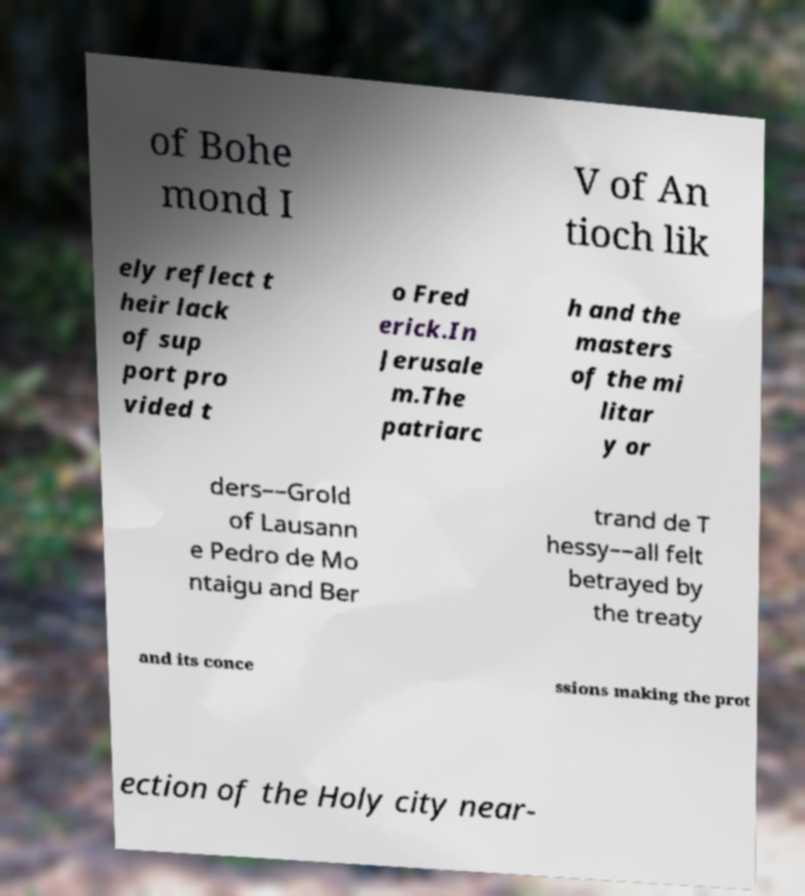Could you assist in decoding the text presented in this image and type it out clearly? of Bohe mond I V of An tioch lik ely reflect t heir lack of sup port pro vided t o Fred erick.In Jerusale m.The patriarc h and the masters of the mi litar y or ders––Grold of Lausann e Pedro de Mo ntaigu and Ber trand de T hessy––all felt betrayed by the treaty and its conce ssions making the prot ection of the Holy city near- 